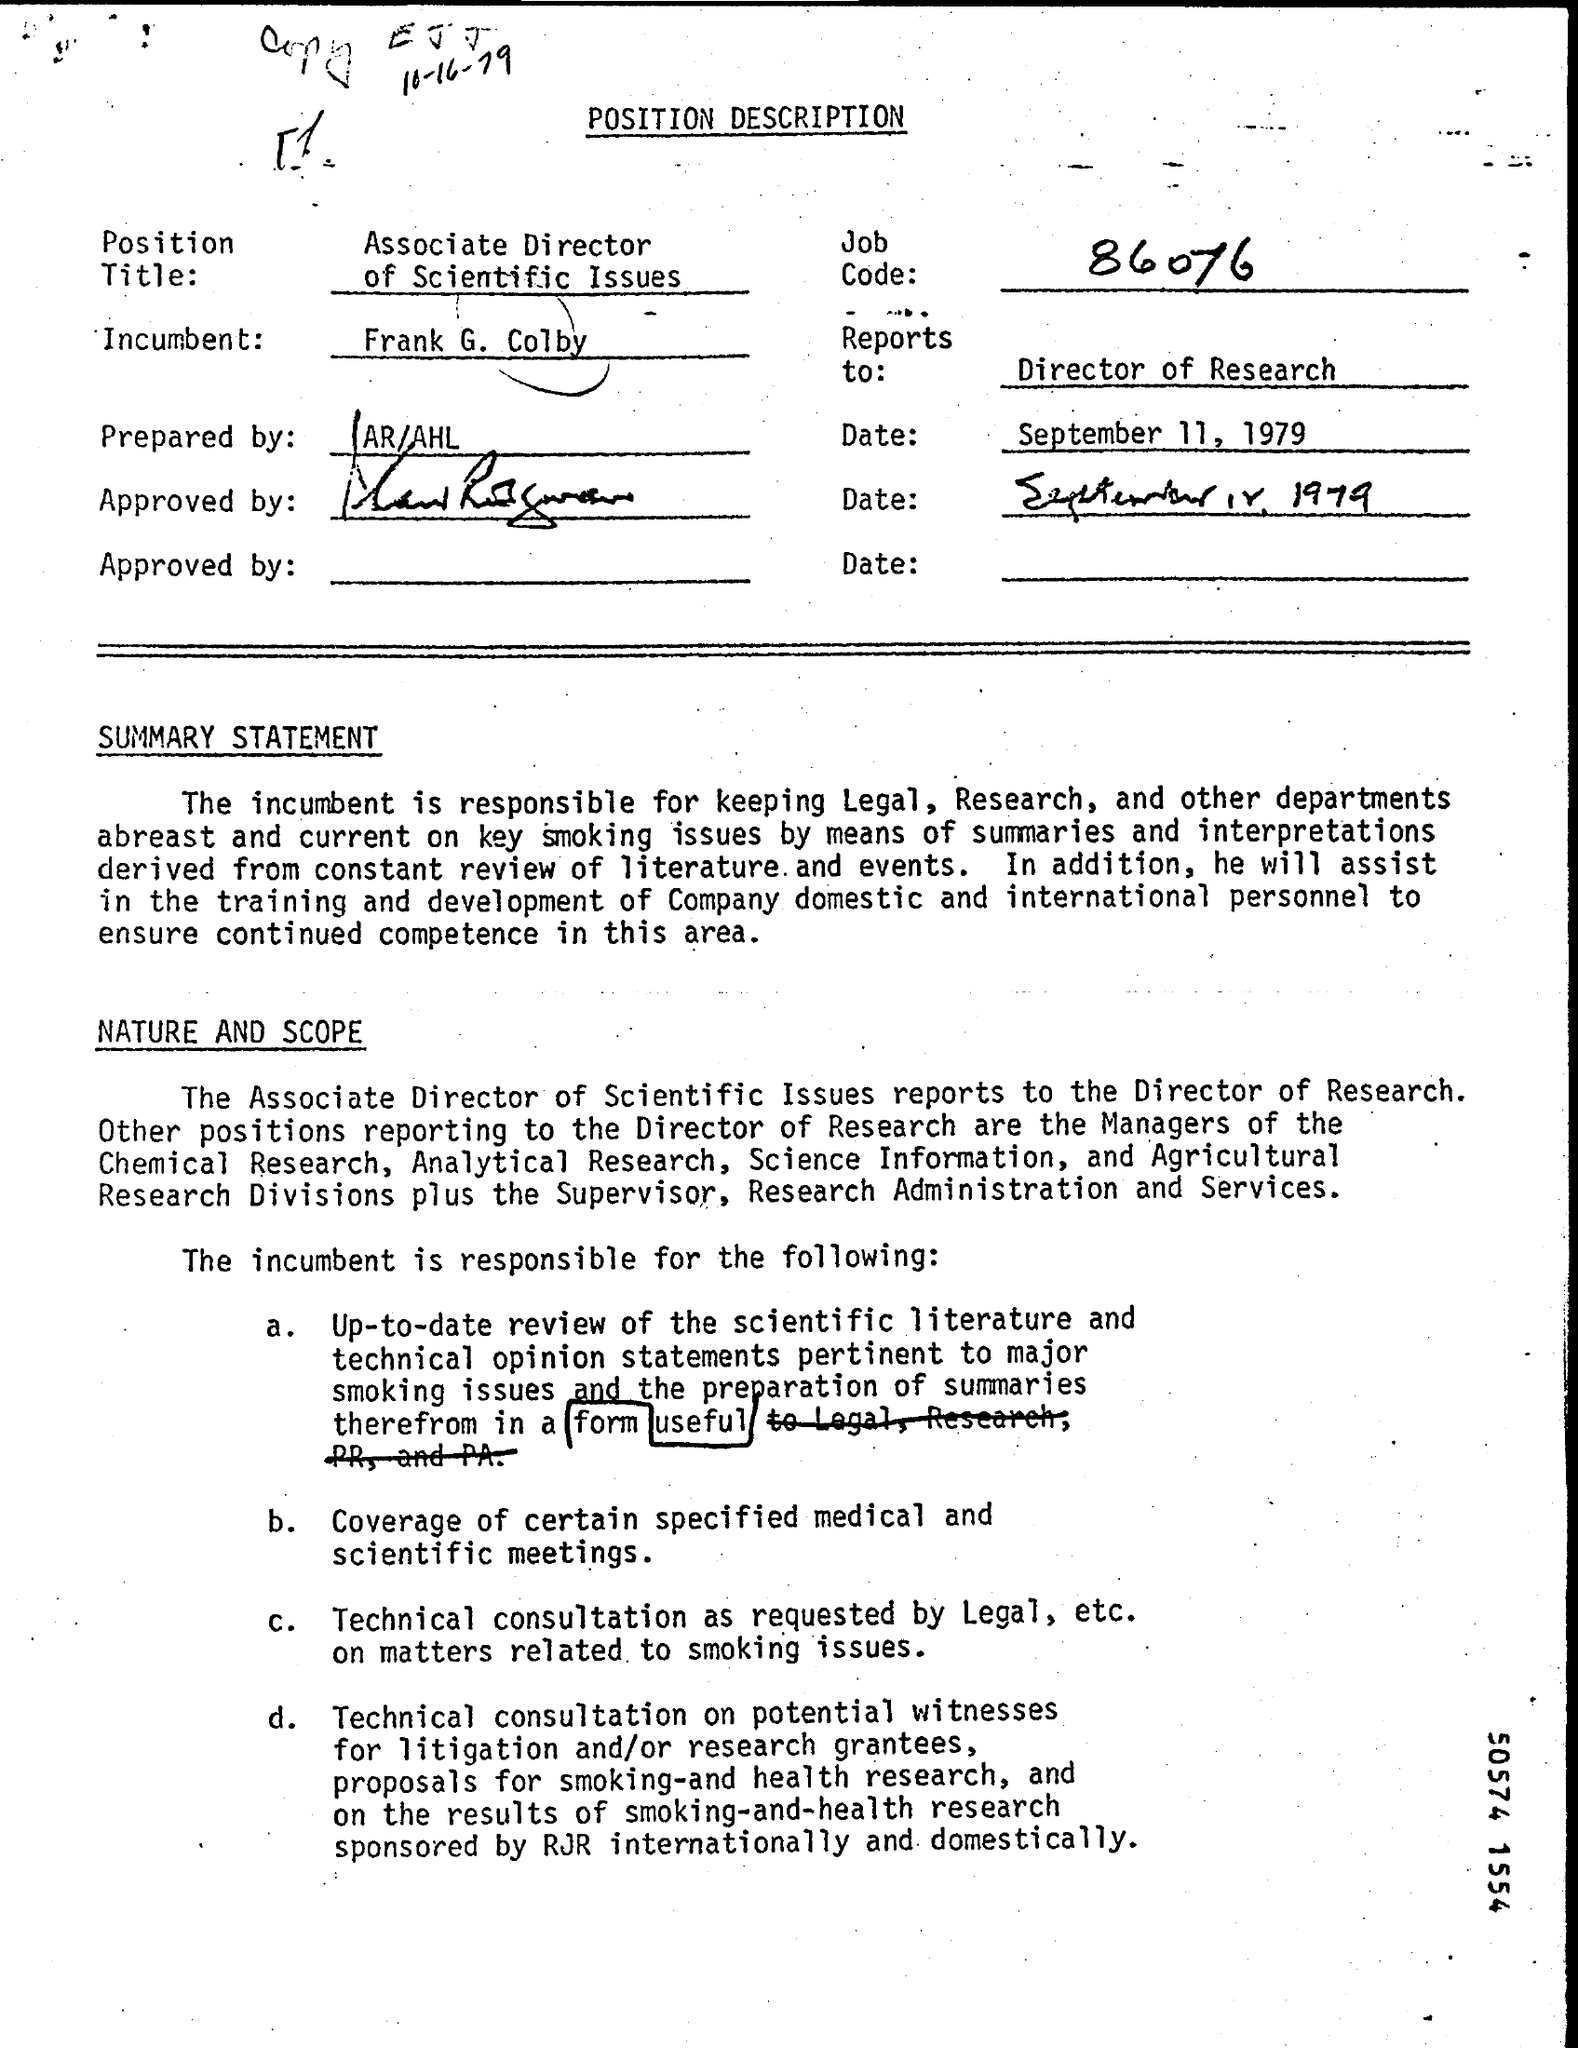What is the job code number mentioned in the description ?
Keep it short and to the point. 86076. By whom this position description is prepared ?
Offer a very short reply. AR/AHL. What is the name of the incumbent mentioned in the position description ?
Make the answer very short. Frank G. Colby. 